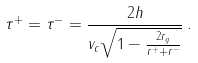<formula> <loc_0><loc_0><loc_500><loc_500>\tau ^ { + } = \tau ^ { - } = \frac { 2 h } { v _ { c } \sqrt { 1 - \frac { 2 r _ { g } } { r ^ { + } + r ^ { - } } } } \, .</formula> 